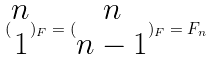<formula> <loc_0><loc_0><loc_500><loc_500>( \begin{matrix} n \\ 1 \end{matrix} ) _ { F } = ( \begin{matrix} n \\ n - 1 \end{matrix} ) _ { F } = F _ { n }</formula> 